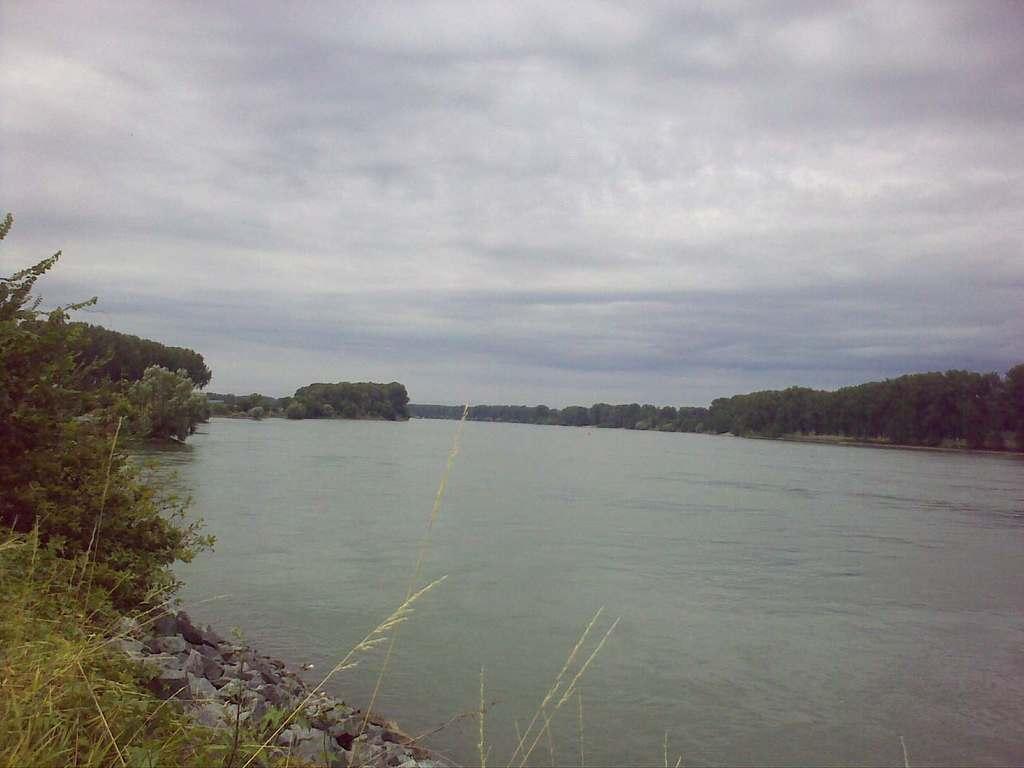How would you summarize this image in a sentence or two? In this picture I can see the lake. In the bottom left I can see many stones. In the background I can see the trees, plants and grass. At the top I can see the sky and clouds. 